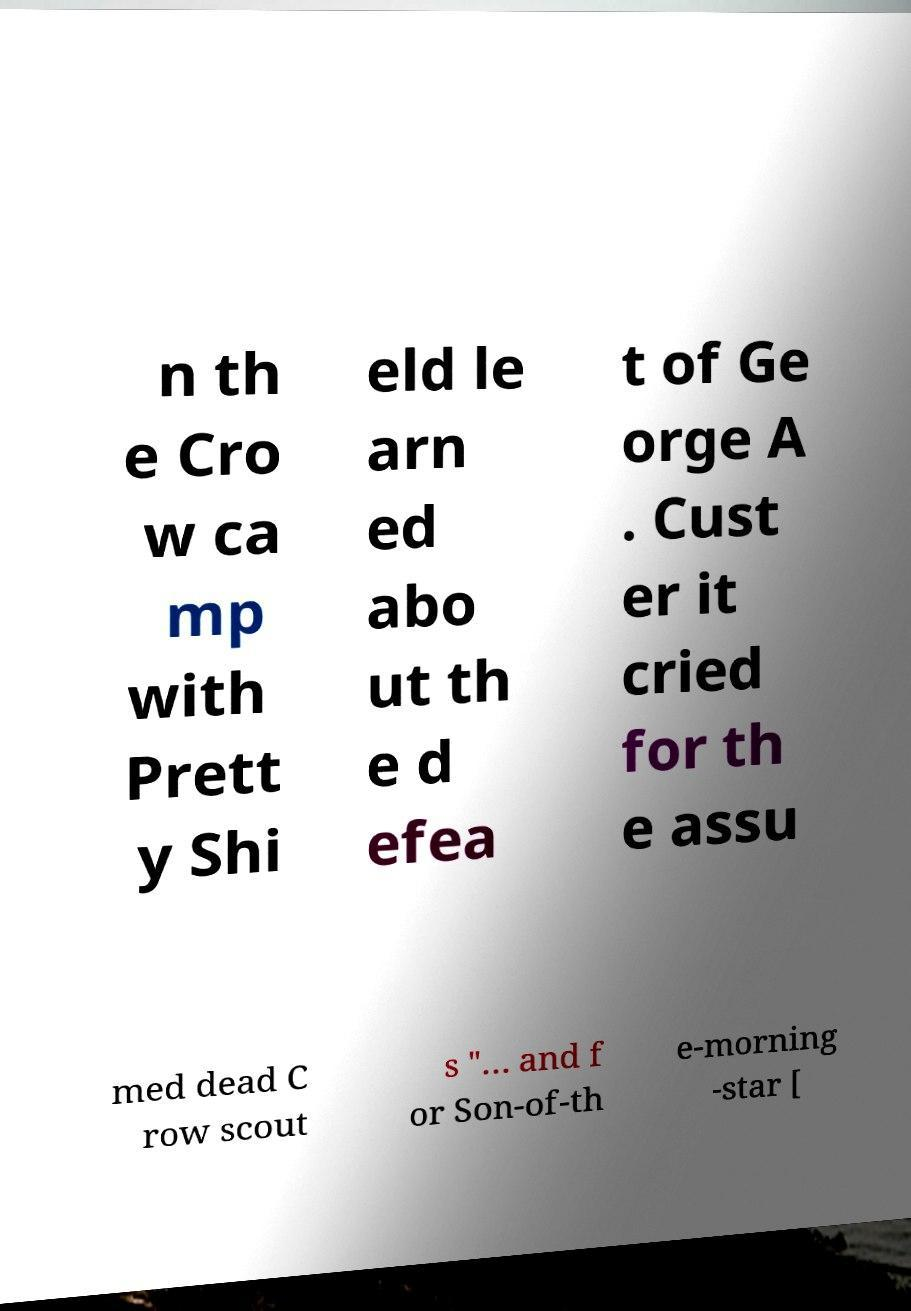What messages or text are displayed in this image? I need them in a readable, typed format. n th e Cro w ca mp with Prett y Shi eld le arn ed abo ut th e d efea t of Ge orge A . Cust er it cried for th e assu med dead C row scout s "… and f or Son-of-th e-morning -star [ 